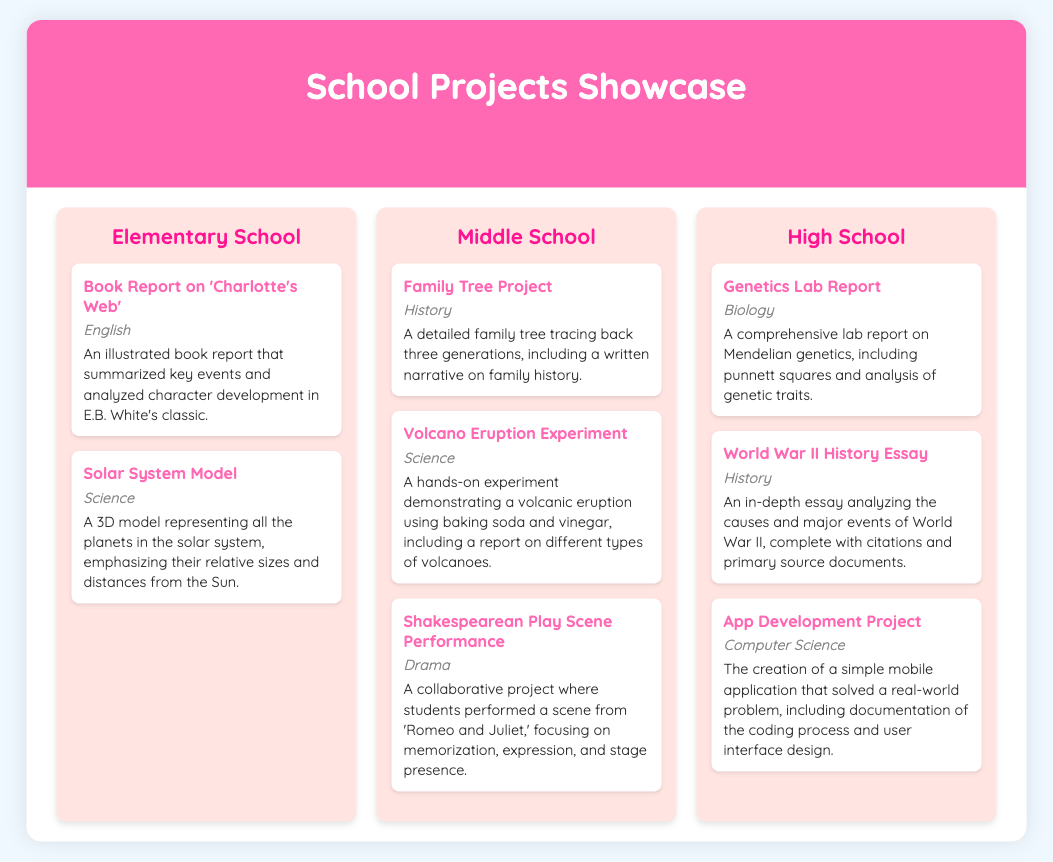What is the first project listed in Elementary School? The first project mentioned under Elementary School is a Book Report on 'Charlotte's Web.'
Answer: Book Report on 'Charlotte's Web' How many projects are in the Middle School section? The Middle School section contains a total of three projects listed.
Answer: 3 What subject does the Solar System Model project fall under? The Solar System Model is categorized under the subject of Science.
Answer: Science Which project focuses on family history? The project that focuses on family history is the Family Tree Project.
Answer: Family Tree Project What was the main activity in the Volcano Eruption Experiment? The main activity involved a hands-on demonstration of volcanic eruption using baking soda and vinegar.
Answer: Baking soda and vinegar How many levels are represented in the document? The document presents three different levels: Elementary School, Middle School, and High School.
Answer: 3 What is the last project listed in High School? The last project mentioned in High School is the App Development Project.
Answer: App Development Project Which subject does the Shakespearean Play Scene Performance belong to? The subject for the Shakespearean Play Scene Performance is Drama.
Answer: Drama What is the total number of science projects across all levels? There are four science projects mentioned in total, two in Elementary School and two in Middle School.
Answer: 4 